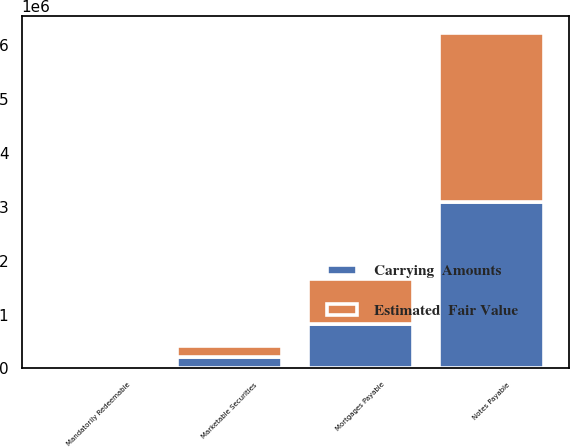Convert chart. <chart><loc_0><loc_0><loc_500><loc_500><stacked_bar_chart><ecel><fcel>Marketable Securities<fcel>Notes Payable<fcel>Mortgages Payable<fcel>Mandatorily Redeemable<nl><fcel>Estimated  Fair Value<fcel>201848<fcel>3.13176e+06<fcel>838738<fcel>3070<nl><fcel>Carrying  Amounts<fcel>212451<fcel>3.095e+06<fcel>824609<fcel>6521<nl></chart> 